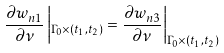Convert formula to latex. <formula><loc_0><loc_0><loc_500><loc_500>\frac { \partial w _ { n 1 } } { \partial \nu } \left | _ { \Gamma _ { 0 } \times ( t _ { 1 } , t _ { 2 } ) } = \frac { \partial w _ { n 3 } } { \partial \nu } \right | _ { \Gamma _ { 0 } \times ( t _ { 1 } , t _ { 2 } ) }</formula> 